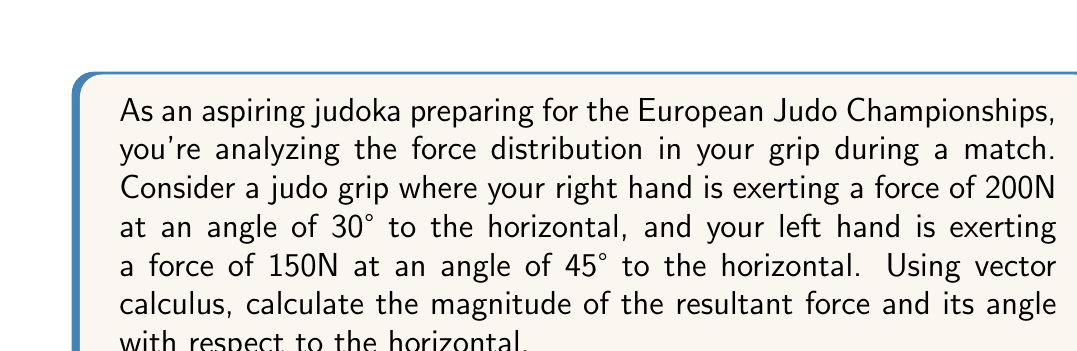Can you solve this math problem? Let's approach this problem step by step using vector calculus:

1) First, we need to express each force as a vector in component form:

   Right hand: $\vec{F_R} = (200 \cos 30°, 200 \sin 30°)$
   Left hand: $\vec{F_L} = (150 \cos 45°, 150 \sin 45°)$

2) Calculate the components:
   
   $\vec{F_R} = (200 \cdot \frac{\sqrt{3}}{2}, 200 \cdot \frac{1}{2}) = (100\sqrt{3}, 100)$
   $\vec{F_L} = (150 \cdot \frac{\sqrt{2}}{2}, 150 \cdot \frac{\sqrt{2}}{2}) = (75\sqrt{2}, 75\sqrt{2})$

3) The resultant force is the vector sum of these two forces:

   $\vec{F_{resultant}} = \vec{F_R} + \vec{F_L} = (100\sqrt{3} + 75\sqrt{2}, 100 + 75\sqrt{2})$

4) To find the magnitude of the resultant force, we use the Pythagorean theorem:

   $|\vec{F_{resultant}}| = \sqrt{(100\sqrt{3} + 75\sqrt{2})^2 + (100 + 75\sqrt{2})^2}$

5) Simplify:
   
   $|\vec{F_{resultant}}| = \sqrt{30000 + 15000\sqrt{6} + 11250 + 10000 + 15000\sqrt{2} + 11250}$
   $= \sqrt{52500 + 15000\sqrt{6} + 15000\sqrt{2}}$
   $\approx 340.28$ N

6) To find the angle, we use the arctangent function:

   $\theta = \arctan(\frac{y}{x}) = \arctan(\frac{100 + 75\sqrt{2}}{100\sqrt{3} + 75\sqrt{2}})$
   $\approx 36.87°$
Answer: The magnitude of the resultant force is approximately 340.28 N, and it forms an angle of approximately 36.87° with the horizontal. 